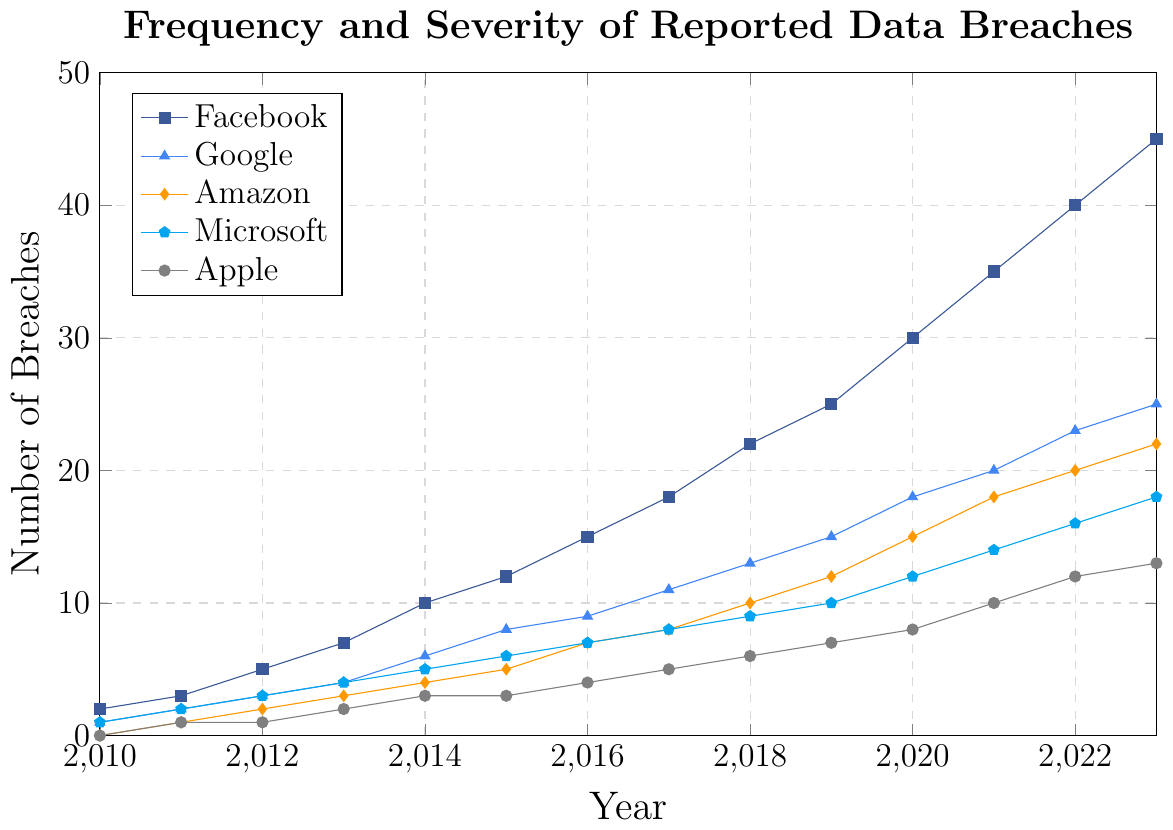What is the trend of data breaches for Facebook from 2010 to 2023? The chart shows an increasing trend in the number of data breaches for Facebook, starting from 2 in 2010 and reaching 45 in 2023. This indicates a consistent rise in breaches over the years.
Answer: Increasing trend Which company showed the steepest increase in data breaches between the years 2015 and 2020? To determine this, we observe the differences in the number of breaches for each company over the period 2015 to 2020. Facebook increased from 12 to 30 (18 breaches), Google from 8 to 18 (10 breaches), Amazon from 5 to 15 (10 breaches), Microsoft from 6 to 12 (6 breaches), and Apple from 3 to 8 (5 breaches). Facebook had the steepest increase.
Answer: Facebook By how much did the number of data breaches in Amazon increase from 2012 to 2018? Looking at the Amazon data points, the number of breaches goes from 2 in 2012 to 10 in 2018. So, the increase is calculated as 10 - 2 = 8.
Answer: 8 Which company had the least data breaches in 2023? Observing the data for 2023, we see the following breaches: Facebook (45), Google (25), Amazon (22), Microsoft (18), and Apple (13). Apple had the least number of breaches.
Answer: Apple How did the data breaches in Microsoft from 2010 to 2023 compare to those in Apple during the same period? Microsoft had data breaches counting as follows: 2010 (1), 2011 (2), 2012 (3), 2013 (4), 2014 (5), 2015 (6), 2016 (7), 2017 (8), 2018 (9), 2019 (10), 2020 (12), 2021 (14), 2022 (16), 2023 (18). Apple’s data breaches were: 2010 (0), 2011 (1), 2012 (1), 2013 (2), 2014 (3), 2015 (3), 2016 (4), 2017 (5), 2018 (6), 2019 (7), 2020 (8), 2021 (10), 2022 (12), 2023 (13). Microsoft consistently had more breaches than Apple each year.
Answer: Microsoft had more breaches each year By what percentage did the number of data breaches for Google increase from 2010 to 2023? Google’s breaches were 1 in 2010 and 25 in 2023. The percentage increase is calculated as ((25-1)/1) * 100 = 2400%.
Answer: 2400% Which year had the highest number of data breaches across all companies collectively? To find this, sum the number of breaches for 2023: Facebook (45) + Google (25) + Amazon (22) + Microsoft (18) + Apple (13) = 123, which is the highest when we compare to the collective sums of all other years.
Answer: 2023 Compare the trend of data breaches for Microsoft and Google from 2015 to 2020. For Microsoft, the breaches increase from 6 in 2015 to 12 in 2020. For Google, the increase is from 8 in 2015 to 18 in 2020. Both companies show an increasing trend, but Google had a steeper increase.
Answer: Increasing, but Google steeper 